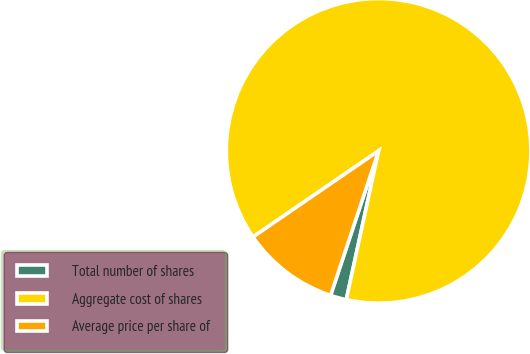<chart> <loc_0><loc_0><loc_500><loc_500><pie_chart><fcel>Total number of shares<fcel>Aggregate cost of shares<fcel>Average price per share of<nl><fcel>1.7%<fcel>87.97%<fcel>10.33%<nl></chart> 